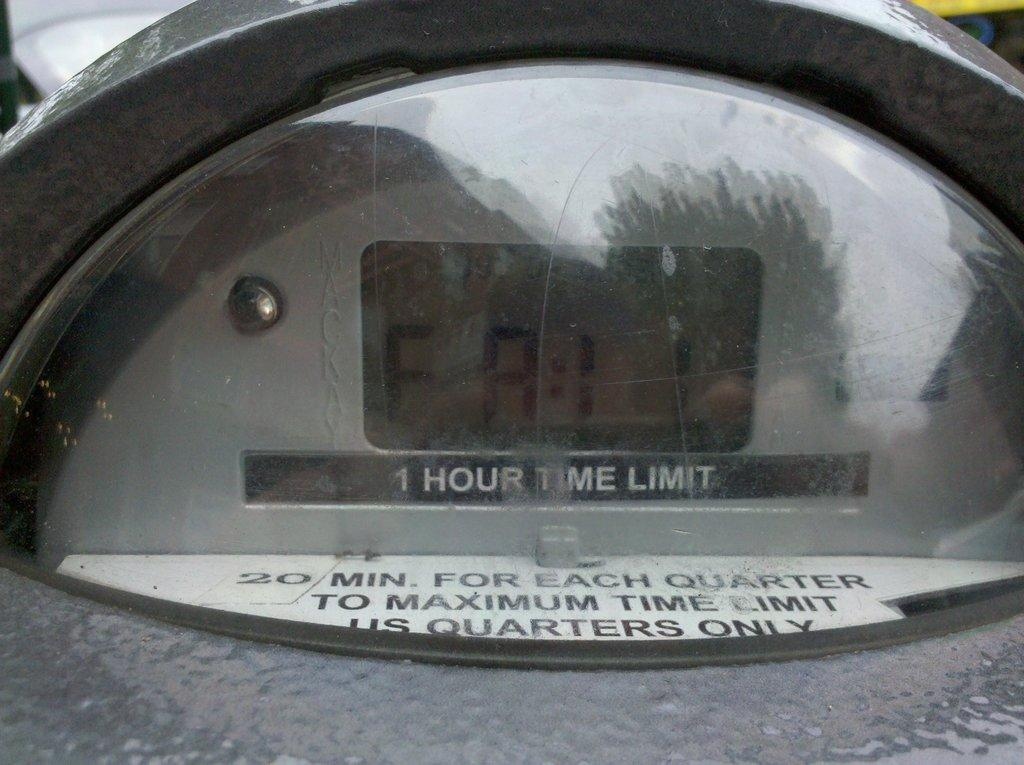<image>
Share a concise interpretation of the image provided. a screen with an hour time limit underneath it 